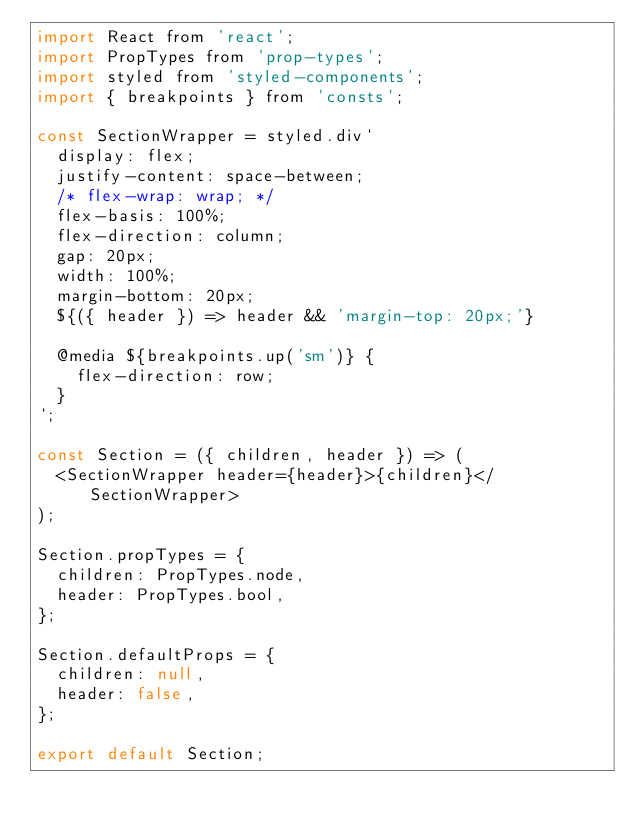<code> <loc_0><loc_0><loc_500><loc_500><_JavaScript_>import React from 'react';
import PropTypes from 'prop-types';
import styled from 'styled-components';
import { breakpoints } from 'consts';

const SectionWrapper = styled.div`
  display: flex;
  justify-content: space-between;
  /* flex-wrap: wrap; */
  flex-basis: 100%;
  flex-direction: column;
  gap: 20px;
  width: 100%;
  margin-bottom: 20px;
  ${({ header }) => header && 'margin-top: 20px;'}

  @media ${breakpoints.up('sm')} {
    flex-direction: row;
  }
`;

const Section = ({ children, header }) => (
  <SectionWrapper header={header}>{children}</SectionWrapper>
);

Section.propTypes = {
  children: PropTypes.node,
  header: PropTypes.bool,
};

Section.defaultProps = {
  children: null,
  header: false,
};

export default Section;
</code> 